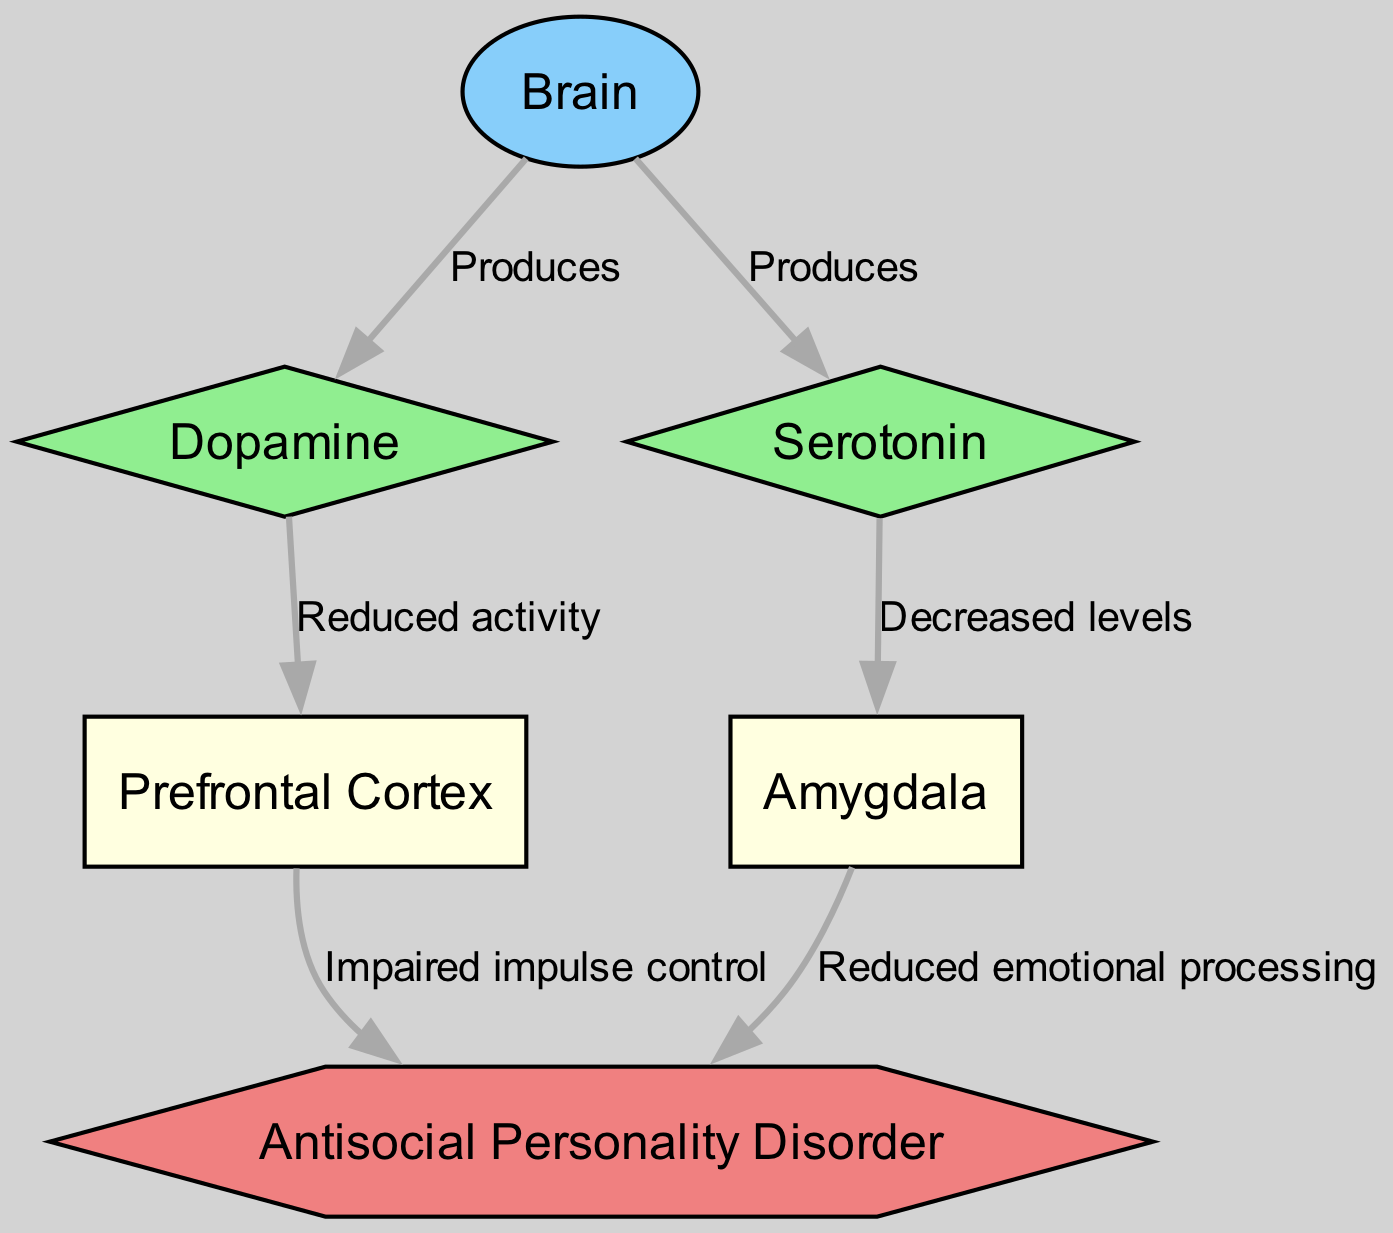What are the two neurotransmitters produced by the brain? The diagram indicates two neurotransmitters produced by the brain: dopamine and serotonin, both of which are labeled as direct outputs from the brain node.
Answer: dopamine, serotonin Which area shows reduced activity due to dopamine? The diagram states that dopamine has reduced activity in the prefrontal cortex, indicated by the edge connecting dopamine to prefrontal cortex with the label "Reduced activity."
Answer: prefrontal cortex What emotional processing aspect is impacted in individuals with antisocial personality disorder? According to the diagram, the amygdala is connected to antisocial personality disorder with the label "Reduced emotional processing," indicating the specific aspect affected.
Answer: Reduced emotional processing How does serotonin affect the amygdala according to the diagram? The edge from serotonin to the amygdala is labeled "Decreased levels," indicating that serotonin negatively influences the levels within the amygdala.
Answer: Decreased levels What is the total number of nodes present in the diagram? The diagram includes six nodes: brain, dopamine, serotonin, prefrontal cortex, amygdala, and antisocial personality disorder, which totals to six.
Answer: 6 Which neurobiological structure is associated with impaired impulse control in antisocial personality disorder? The connection from the prefrontal cortex to antisocial personality disorder is labeled "Impaired impulse control," showing that this structure plays a significant role in impulse management.
Answer: prefrontal cortex How many edges point towards the antisocial personality disorder node? There are two edges leading towards the antisocial personality disorder node, one from the prefrontal cortex (labeled "Impaired impulse control") and another from the amygdala (labeled "Reduced emotional processing").
Answer: 2 What is the relationship between serotonin and antisocial personality disorder in this diagram? The diagram shows that serotonin has a direct effect on the amygdala, where reduced levels may contribute to the emotional and behavioral aspects of antisocial personality disorder, but there is no direct edge connecting serotonin to ASPD.
Answer: No direct connection Why might dopamine imbalances relate to impulsivity in antisocial personality disorder? The diagram indicates that dopamine, through reduced activity in the prefrontal cortex, which is implicated in impulse control, suggests that dopamine imbalances may directly contribute to impulsive behaviors seen in antisocial personality disorder.
Answer: Impaired impulse control 